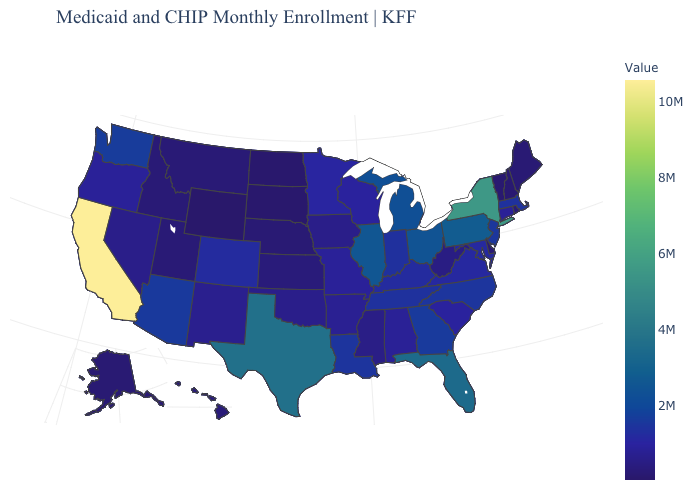Does the map have missing data?
Give a very brief answer. No. Among the states that border Ohio , does West Virginia have the lowest value?
Concise answer only. Yes. Which states hav the highest value in the West?
Concise answer only. California. Among the states that border New Hampshire , does Massachusetts have the highest value?
Give a very brief answer. Yes. Which states have the lowest value in the South?
Concise answer only. Delaware. Does the map have missing data?
Quick response, please. No. Among the states that border Rhode Island , which have the highest value?
Short answer required. Massachusetts. Does Pennsylvania have the highest value in the Northeast?
Keep it brief. No. 